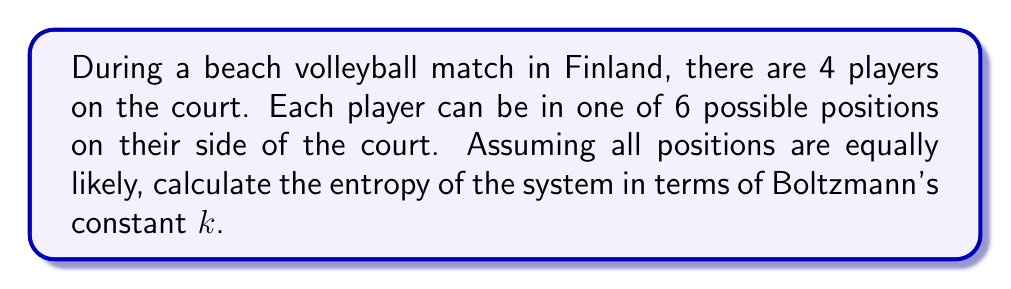Give your solution to this math problem. Let's approach this step-by-step:

1) In statistical mechanics, entropy $S$ is given by the Boltzmann formula:

   $$S = k \ln W$$

   where $k$ is Boltzmann's constant and $W$ is the number of microstates.

2) In this case, we need to calculate the total number of possible arrangements (microstates) of the players.

3) For the first player on one team, there are 6 possible positions.

4) For the second player on the same team, there are 5 remaining positions.

5) On the other team, the process is the same. So we have:

   $$W = 6 \times 5 \times 6 \times 5 = 900$$

6) Now we can plug this into our entropy formula:

   $$S = k \ln 900$$

7) Using the properties of logarithms:

   $$S = k \ln (2^2 \times 3^2 \times 5^2)$$
   $$S = k (2\ln 2 + 2\ln 3 + 2\ln 5)$$

8) This can be simplified to:

   $$S = 2k (\ln 2 + \ln 3 + \ln 5)$$
Answer: $S = 2k (\ln 2 + \ln 3 + \ln 5)$ 